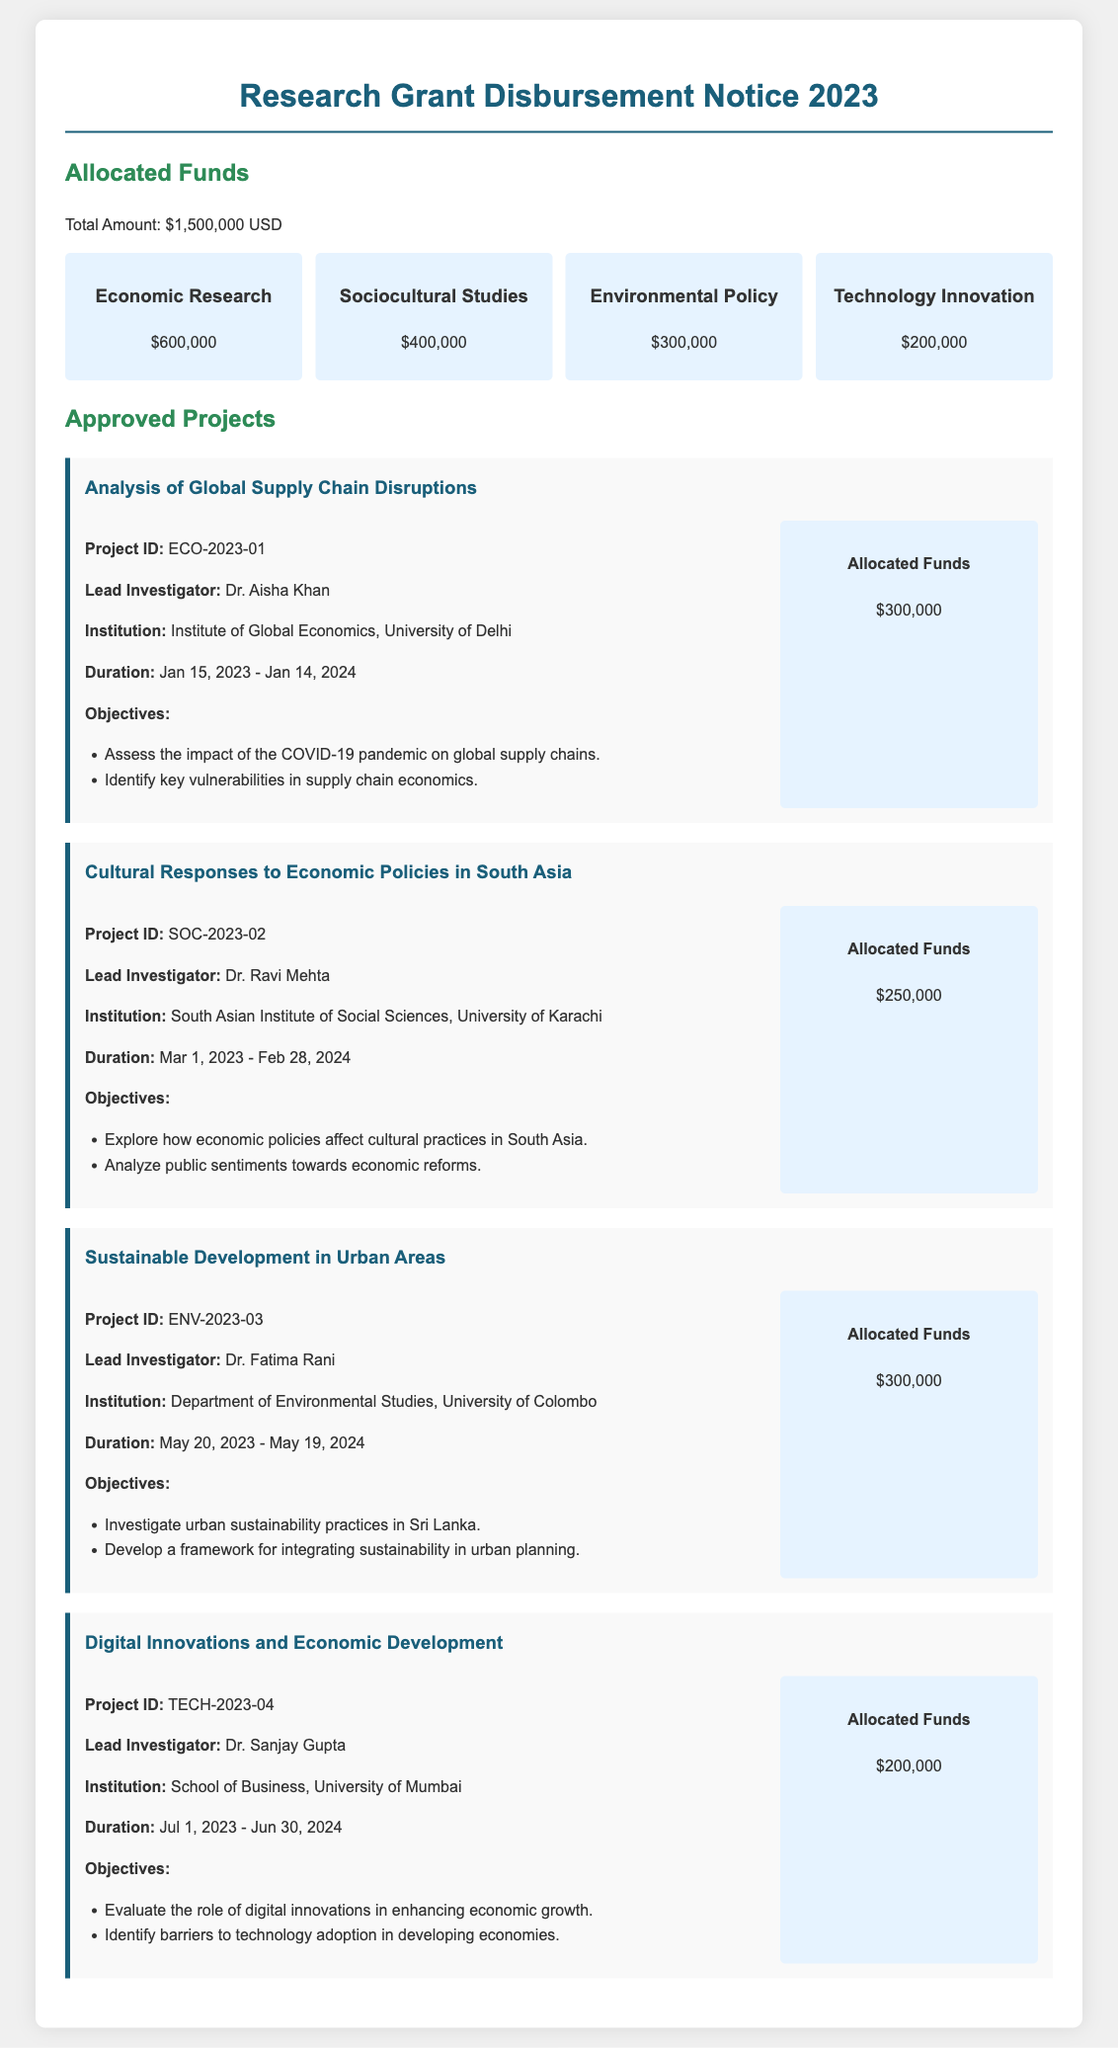What is the total amount allocated for funds? The total amount for funds specified in the document is noted as $1,500,000 USD.
Answer: $1,500,000 USD Who is the lead investigator for the project "Cultural Responses to Economic Policies in South Asia"? The lead investigator for this project is Dr. Ravi Mehta, as mentioned in the project details.
Answer: Dr. Ravi Mehta What is the duration of the project "Digital Innovations and Economic Development"? The duration of the project is stated as from July 1, 2023, to June 30, 2024.
Answer: July 1, 2023 - June 30, 2024 How much funding is allocated to Environmental Policy research? The allocated funding for Environmental Policy is explicitly mentioned as $300,000.
Answer: $300,000 What are the main objectives of the project "Analysis of Global Supply Chain Disruptions"? The main objectives include assessing the impact of COVID-19 and identifying vulnerabilities in supply chain economics, as listed in the project description.
Answer: Assess the impact of the COVID-19 pandemic on global supply chains; Identify key vulnerabilities in supply chain economics Which institution is leading the project on sustainable development? The project on sustainable development is led by the Department of Environmental Studies at the University of Colombo.
Answer: University of Colombo How many projects are listed in the document? The document details a total of four approved projects.
Answer: Four What is the allocated fund for the project "Sustainable Development in Urban Areas"? The document states that this project has been allocated $300,000 in funds.
Answer: $300,000 